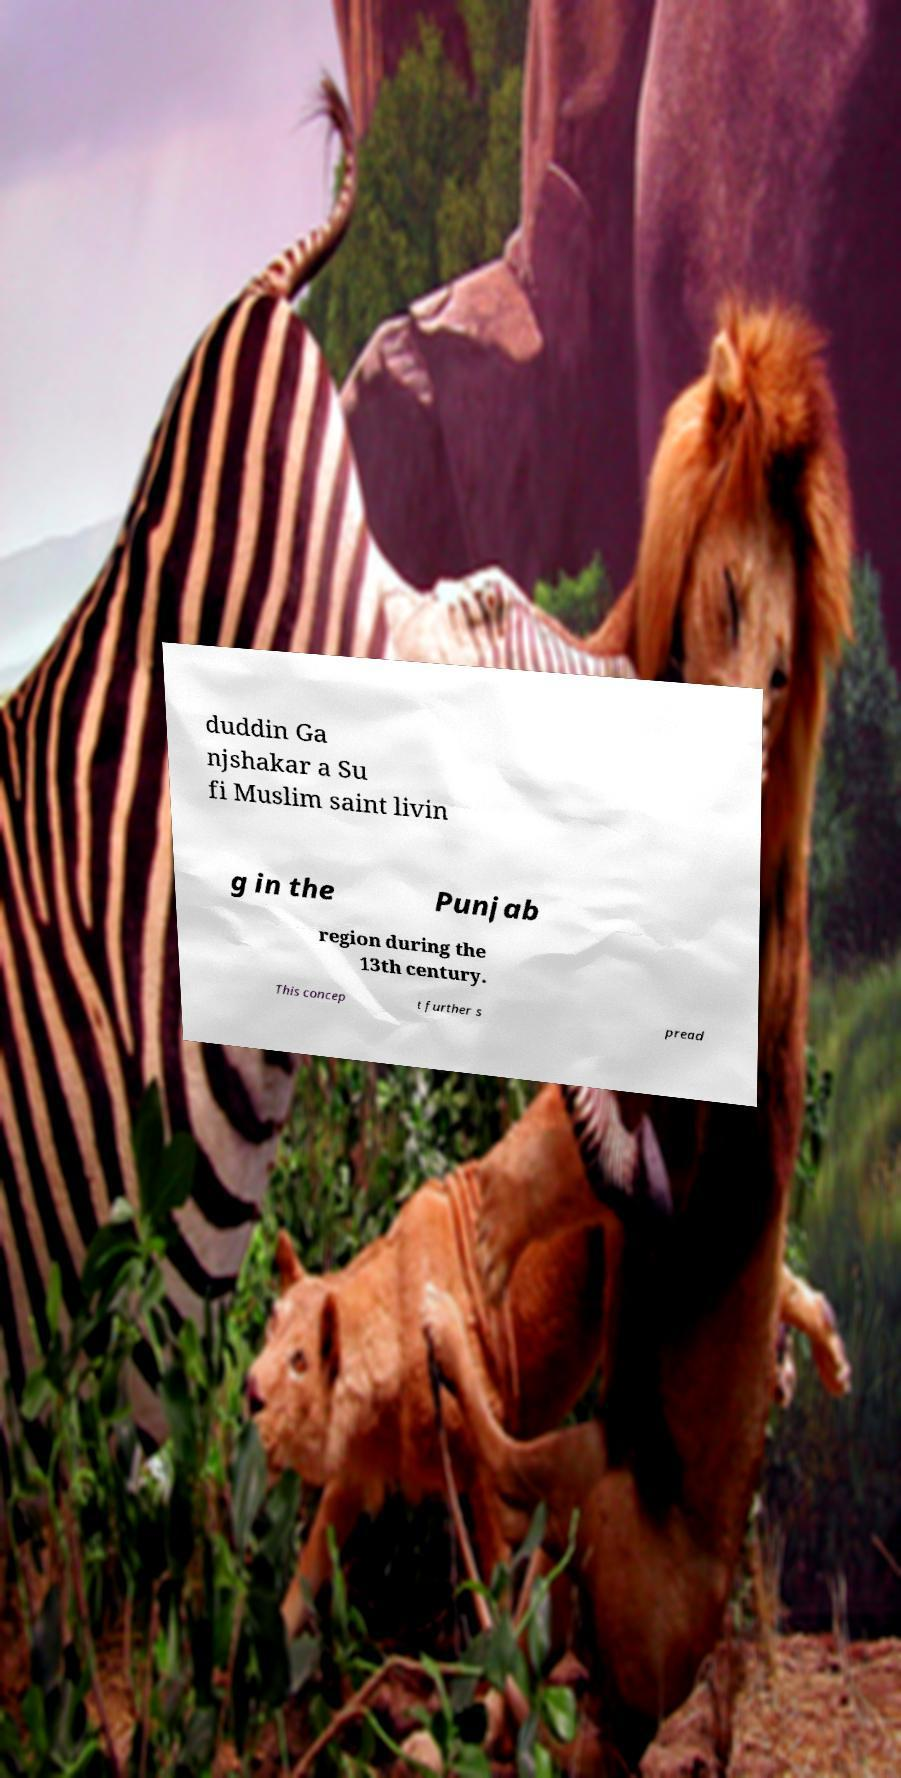Please read and relay the text visible in this image. What does it say? duddin Ga njshakar a Su fi Muslim saint livin g in the Punjab region during the 13th century. This concep t further s pread 